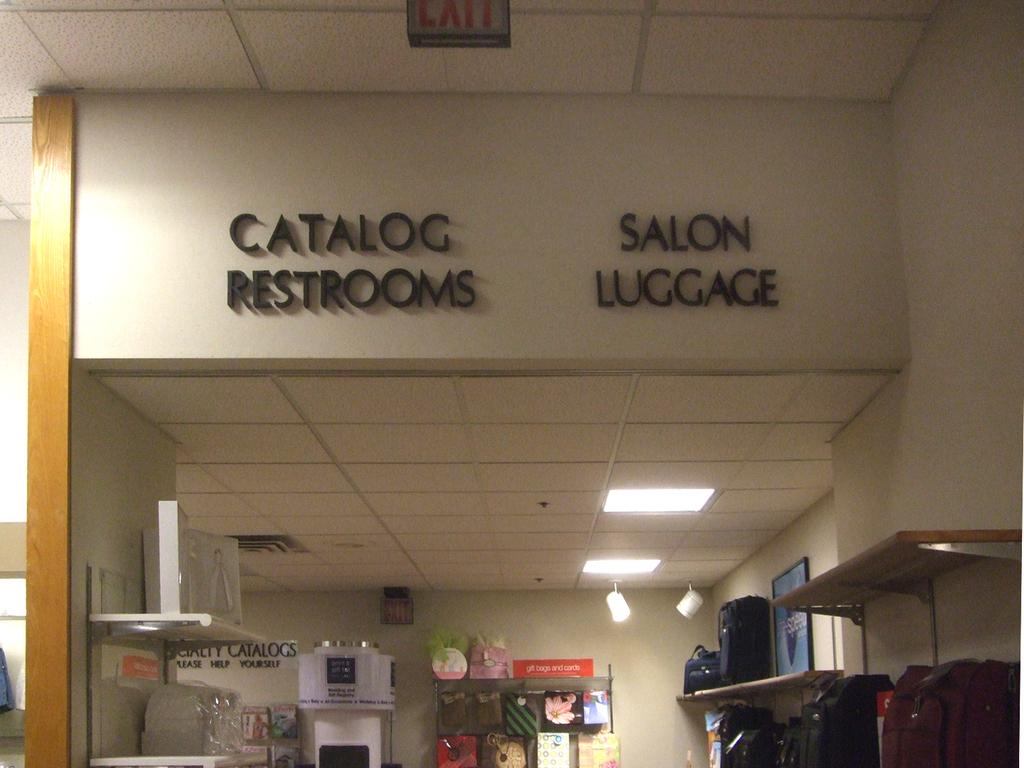How many stores fronts are displayed?
Your answer should be compact. 2. What can be purchased on the right?
Offer a very short reply. Luggage. 